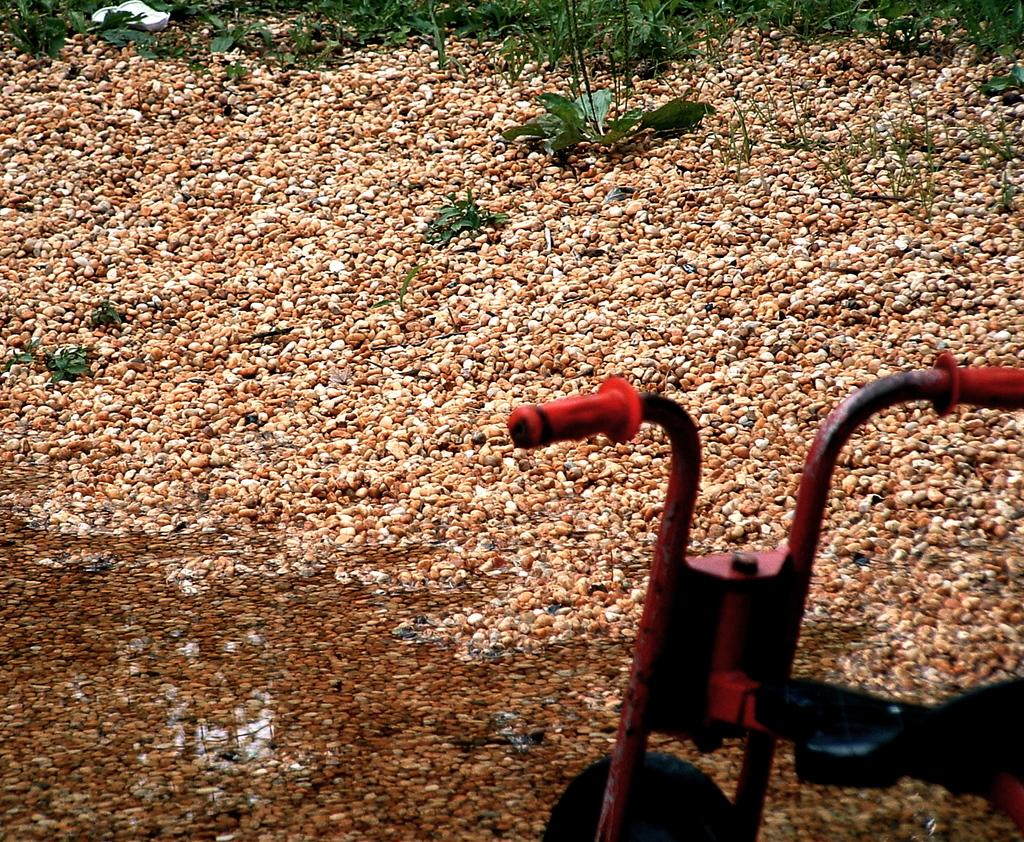What can be seen on the right side of the image? There is a vehicle on the right side of the image. What type of natural elements are visible in the background of the image? There are plants in the background of the image. What type of surface is at the bottom of the image? There are stones at the bottom of the image. What type of kettle is being used to position the plants in the image? There is no kettle present in the image, and the plants are not being positioned by any object. 